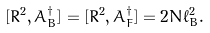<formula> <loc_0><loc_0><loc_500><loc_500>[ R ^ { 2 } , A ^ { \dagger } _ { B } ] = [ R ^ { 2 } , A ^ { \dagger } _ { F } ] = 2 N \ell _ { B } ^ { 2 } .</formula> 